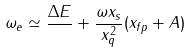<formula> <loc_0><loc_0><loc_500><loc_500>\omega _ { e } \simeq \frac { \Delta E } { } + \frac { \omega x _ { s } } { x _ { q } ^ { 2 } } ( x _ { f p } + A )</formula> 